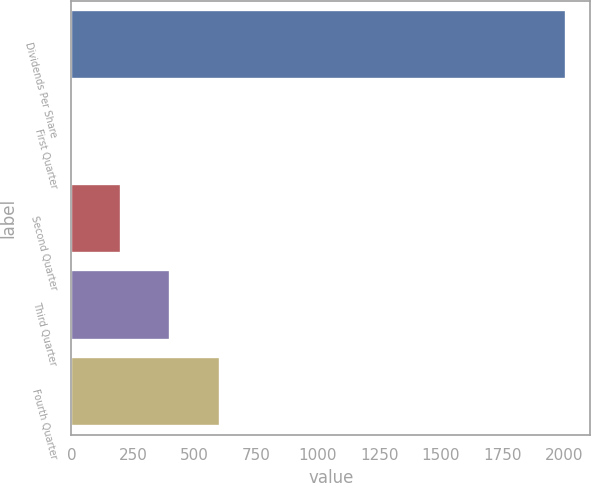<chart> <loc_0><loc_0><loc_500><loc_500><bar_chart><fcel>Dividends Per Share<fcel>First Quarter<fcel>Second Quarter<fcel>Third Quarter<fcel>Fourth Quarter<nl><fcel>2006<fcel>0.21<fcel>200.79<fcel>401.37<fcel>601.95<nl></chart> 